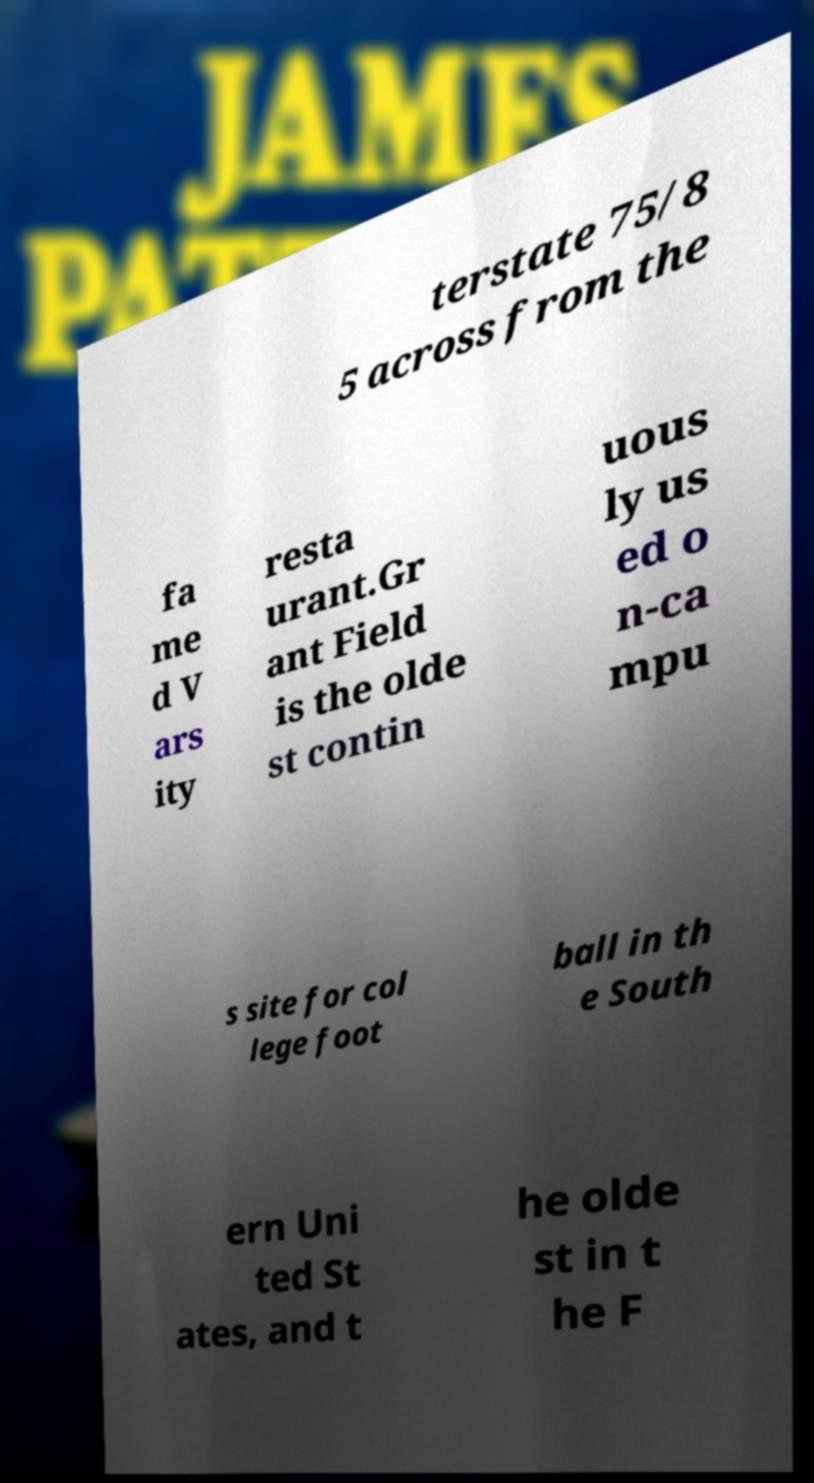Can you accurately transcribe the text from the provided image for me? terstate 75/8 5 across from the fa me d V ars ity resta urant.Gr ant Field is the olde st contin uous ly us ed o n-ca mpu s site for col lege foot ball in th e South ern Uni ted St ates, and t he olde st in t he F 